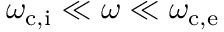<formula> <loc_0><loc_0><loc_500><loc_500>\omega _ { c , i } \ll \omega \ll \omega _ { c , e }</formula> 